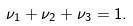<formula> <loc_0><loc_0><loc_500><loc_500>\nu _ { 1 } + \nu _ { 2 } + \nu _ { 3 } = 1 .</formula> 